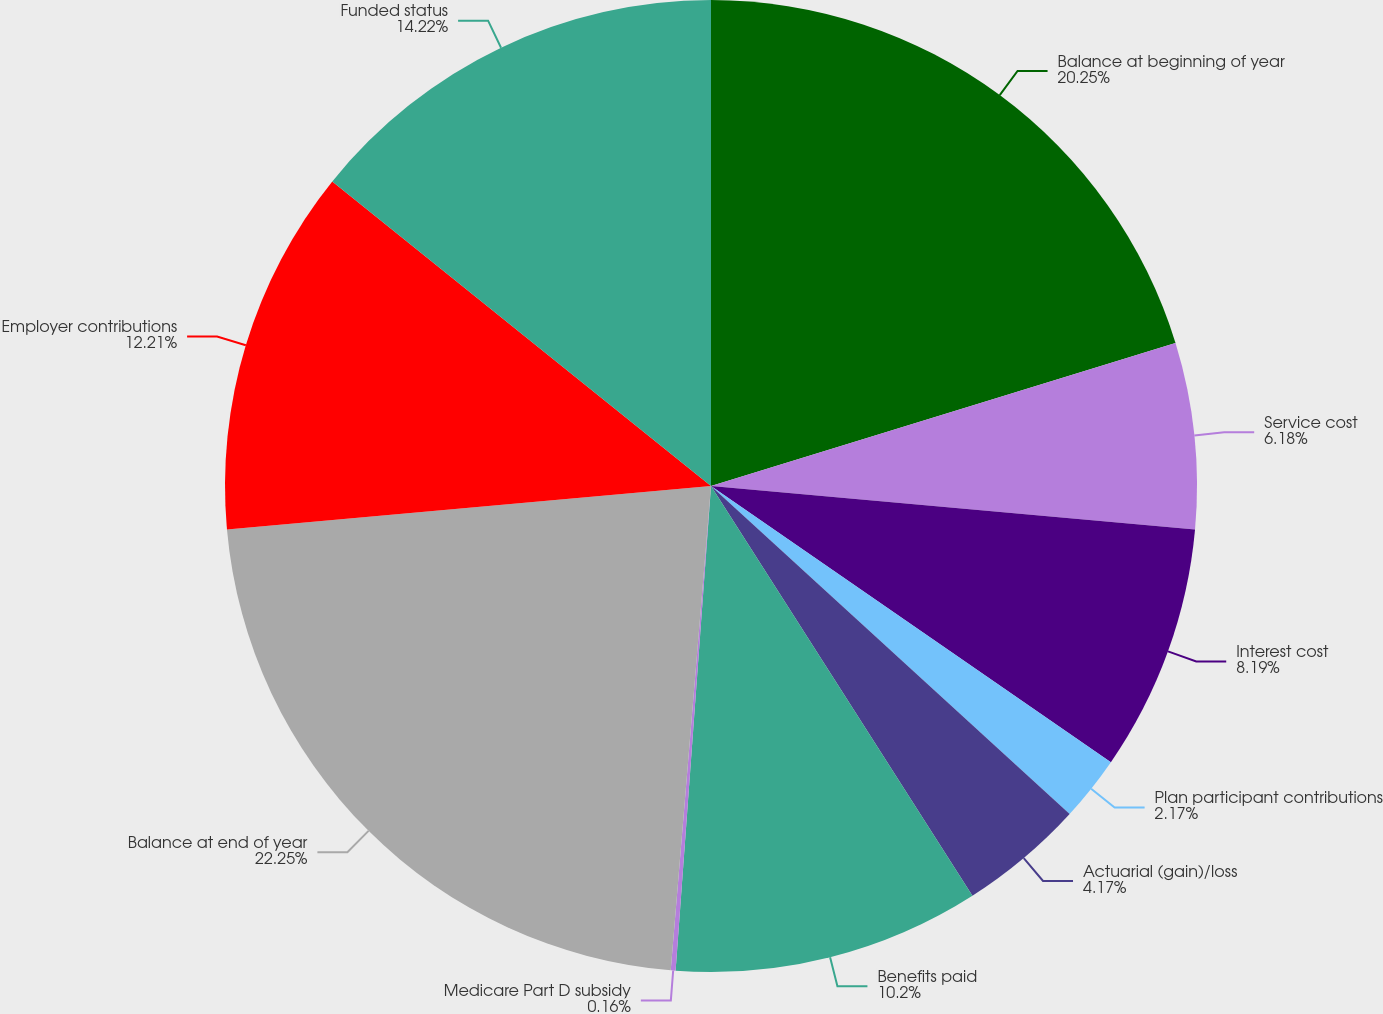<chart> <loc_0><loc_0><loc_500><loc_500><pie_chart><fcel>Balance at beginning of year<fcel>Service cost<fcel>Interest cost<fcel>Plan participant contributions<fcel>Actuarial (gain)/loss<fcel>Benefits paid<fcel>Medicare Part D subsidy<fcel>Balance at end of year<fcel>Employer contributions<fcel>Funded status<nl><fcel>20.25%<fcel>6.18%<fcel>8.19%<fcel>2.17%<fcel>4.17%<fcel>10.2%<fcel>0.16%<fcel>22.25%<fcel>12.21%<fcel>14.22%<nl></chart> 